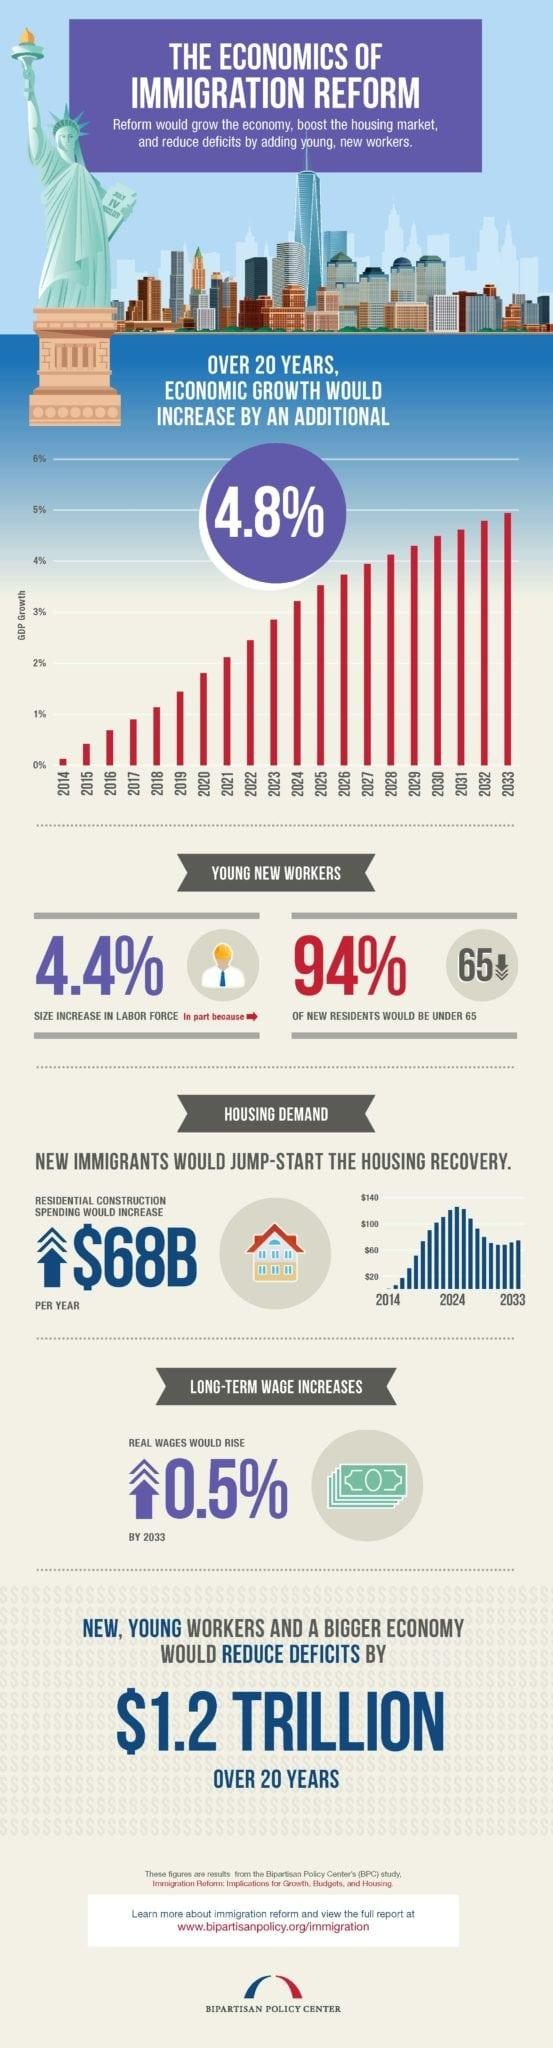Outline some significant characteristics in this image. In 20 years, the rate of economic growth is projected to increase by 4.8%. The demand for housing is expected to be high in 2024. 